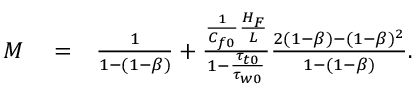Convert formula to latex. <formula><loc_0><loc_0><loc_500><loc_500>\begin{array} { r l r } { M } & = } & { \frac { 1 } { 1 - ( 1 - \beta ) } + \frac { \frac { 1 } { C _ { f 0 } } \frac { H _ { F } } { L } } { 1 - \frac { \tau _ { t 0 } } { \tau _ { w 0 } } } \frac { 2 ( 1 - \beta ) - ( 1 - \beta ) ^ { 2 } } { 1 - ( 1 - \beta ) } . } \end{array}</formula> 